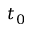Convert formula to latex. <formula><loc_0><loc_0><loc_500><loc_500>t _ { 0 }</formula> 